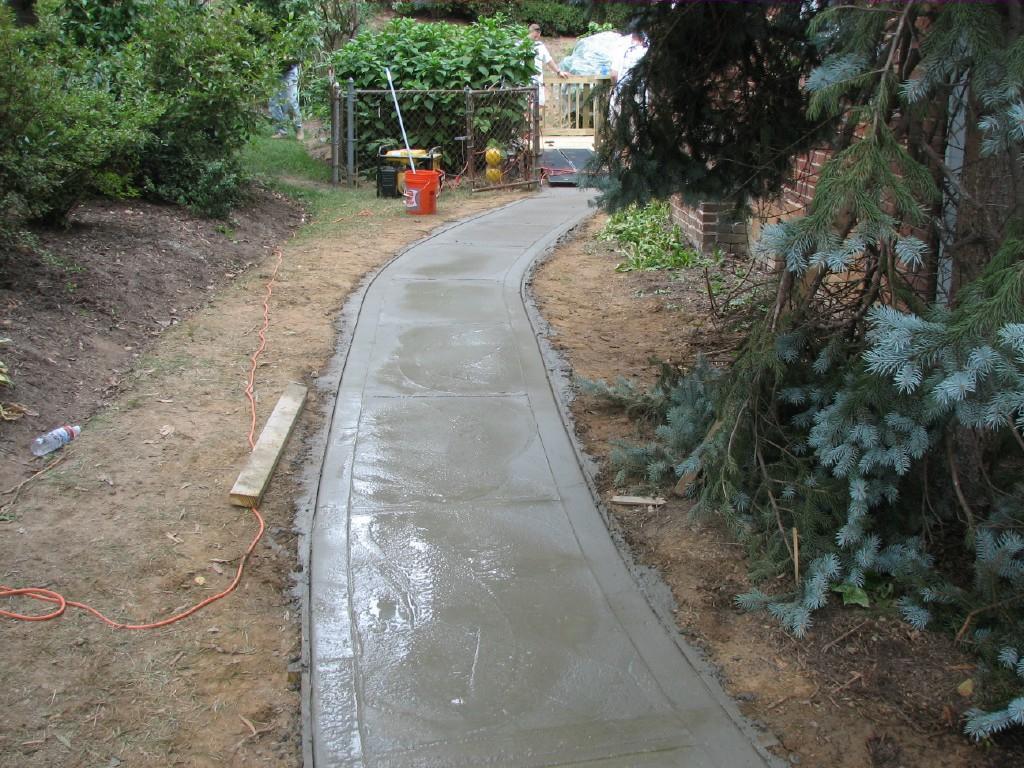In one or two sentences, can you explain what this image depicts? In this picture we can see a concrete path, beside this concrete path we can see a bottle, wooden stick and some objects on the ground and in the background we can see trees, wall, people and some objects. 